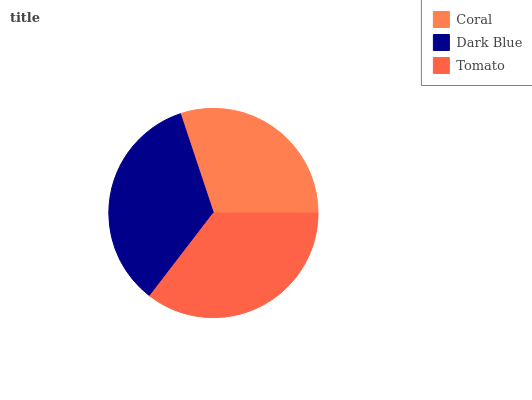Is Coral the minimum?
Answer yes or no. Yes. Is Tomato the maximum?
Answer yes or no. Yes. Is Dark Blue the minimum?
Answer yes or no. No. Is Dark Blue the maximum?
Answer yes or no. No. Is Dark Blue greater than Coral?
Answer yes or no. Yes. Is Coral less than Dark Blue?
Answer yes or no. Yes. Is Coral greater than Dark Blue?
Answer yes or no. No. Is Dark Blue less than Coral?
Answer yes or no. No. Is Dark Blue the high median?
Answer yes or no. Yes. Is Dark Blue the low median?
Answer yes or no. Yes. Is Tomato the high median?
Answer yes or no. No. Is Coral the low median?
Answer yes or no. No. 